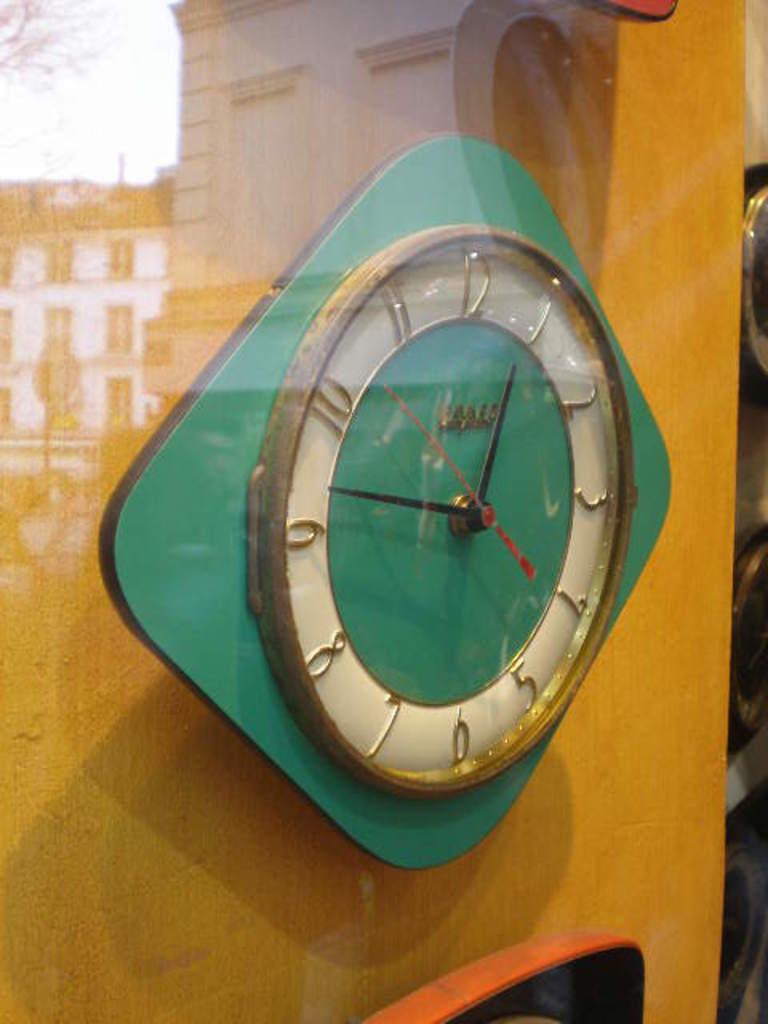What time is it?
Your response must be concise. 12:47. What number does the small hand point to?
Provide a succinct answer. 1. 